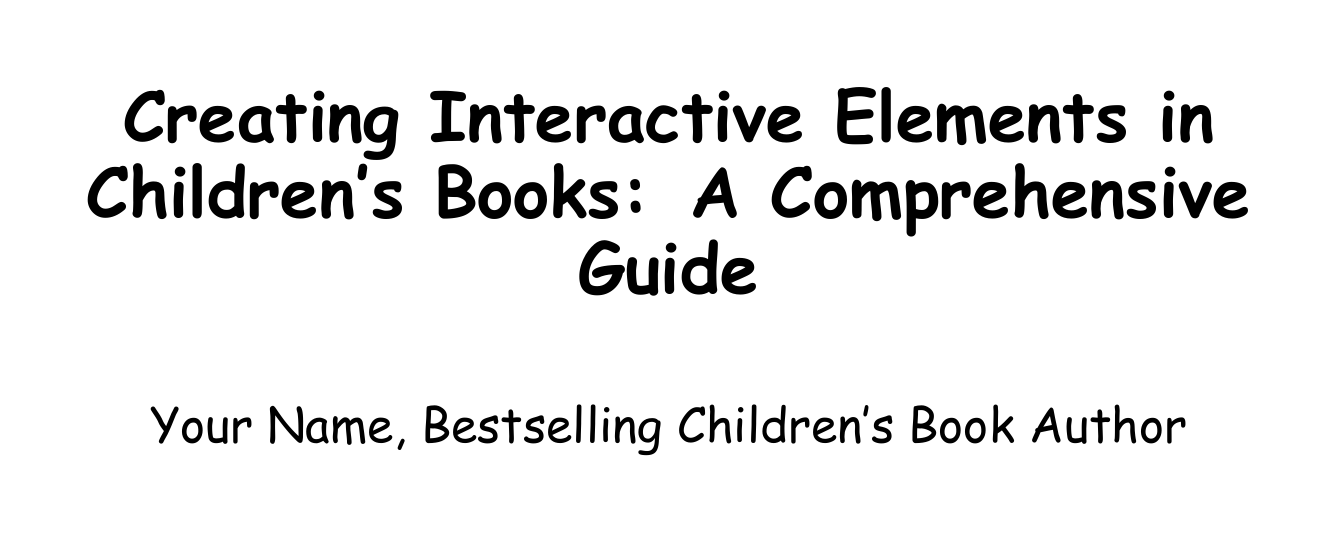What is the title of the manual? The title of the manual is stated in the title section of the document.
Answer: Creating Interactive Elements in Children's Books: A Comprehensive Guide Who is the author of the manual? The author of the manual is mentioned on the title page.
Answer: Your Name, Bestselling Children's Book Author What is one type of interactive element discussed in the document? The document lists types of interactive features in its overview section.
Answer: Pop-ups How many chapters are in the manual? The total number of chapters is found in the table of contents.
Answer: Nine What should be considered when planning interactive elements for a specific age group? The planning section discusses determining appropriate elements for different age groups.
Answer: Age-appropriate interactive elements What is a basic mechanism for creating pop-ups? The section on pop-up elements lists basic mechanisms used for them.
Answer: V-folds Which children's book is analyzed in the case studies section? The case studies section includes specific interactive children's books as examples.
Answer: The Very Hungry Caterpillar Which future trend is mentioned for interactive children's books? The future trends section highlights various upcoming trends in interactive books.
Answer: Augmented reality features What does the appendix titled "Resources" contain? The resources section lists helpful items for authors and illustrators.
Answer: List of recommended tools and materials 